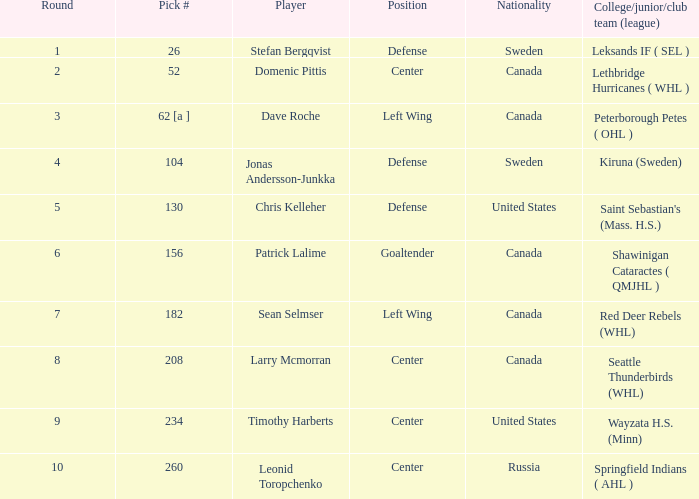Can you parse all the data within this table? {'header': ['Round', 'Pick #', 'Player', 'Position', 'Nationality', 'College/junior/club team (league)'], 'rows': [['1', '26', 'Stefan Bergqvist', 'Defense', 'Sweden', 'Leksands IF ( SEL )'], ['2', '52', 'Domenic Pittis', 'Center', 'Canada', 'Lethbridge Hurricanes ( WHL )'], ['3', '62 [a ]', 'Dave Roche', 'Left Wing', 'Canada', 'Peterborough Petes ( OHL )'], ['4', '104', 'Jonas Andersson-Junkka', 'Defense', 'Sweden', 'Kiruna (Sweden)'], ['5', '130', 'Chris Kelleher', 'Defense', 'United States', "Saint Sebastian's (Mass. H.S.)"], ['6', '156', 'Patrick Lalime', 'Goaltender', 'Canada', 'Shawinigan Cataractes ( QMJHL )'], ['7', '182', 'Sean Selmser', 'Left Wing', 'Canada', 'Red Deer Rebels (WHL)'], ['8', '208', 'Larry Mcmorran', 'Center', 'Canada', 'Seattle Thunderbirds (WHL)'], ['9', '234', 'Timothy Harberts', 'Center', 'United States', 'Wayzata H.S. (Minn)'], ['10', '260', 'Leonid Toropchenko', 'Center', 'Russia', 'Springfield Indians ( AHL )']]} What is the pick number for round 2? 52.0. 